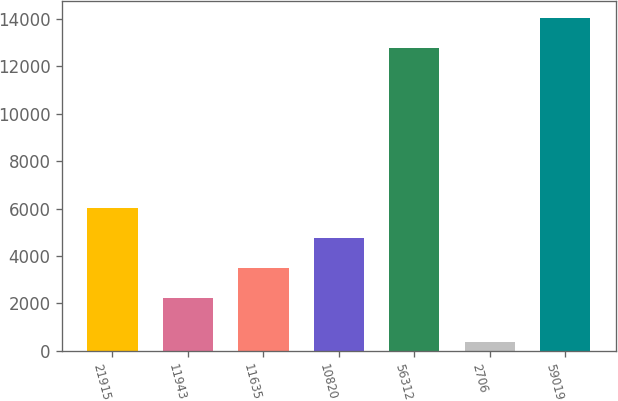Convert chart. <chart><loc_0><loc_0><loc_500><loc_500><bar_chart><fcel>21915<fcel>11943<fcel>11635<fcel>10820<fcel>56312<fcel>2706<fcel>59019<nl><fcel>6036.18<fcel>2204.7<fcel>3481.86<fcel>4759.02<fcel>12771.6<fcel>347.5<fcel>14048.8<nl></chart> 